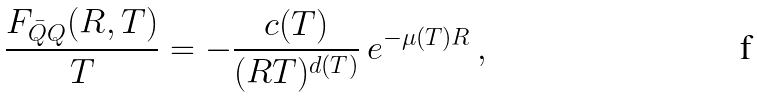Convert formula to latex. <formula><loc_0><loc_0><loc_500><loc_500>\frac { F _ { \bar { Q } Q } ( R , T ) } { T } = - \frac { c ( T ) } { ( R T ) ^ { d ( T ) } } \, e ^ { - \mu ( T ) R } \, ,</formula> 